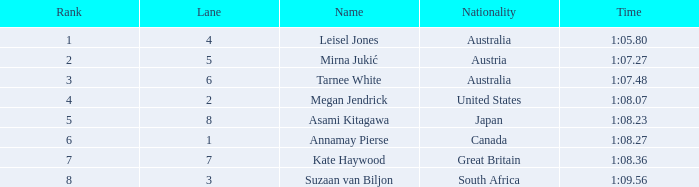What is the nationality of the swimmer in lane 4 or higher, who has a ranking of 5 or above? Great Britain. 